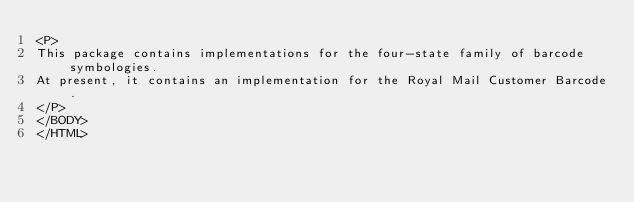<code> <loc_0><loc_0><loc_500><loc_500><_HTML_><P>
This package contains implementations for the four-state family of barcode symbologies.
At present, it contains an implementation for the Royal Mail Customer Barcode.
</P>
</BODY>
</HTML></code> 